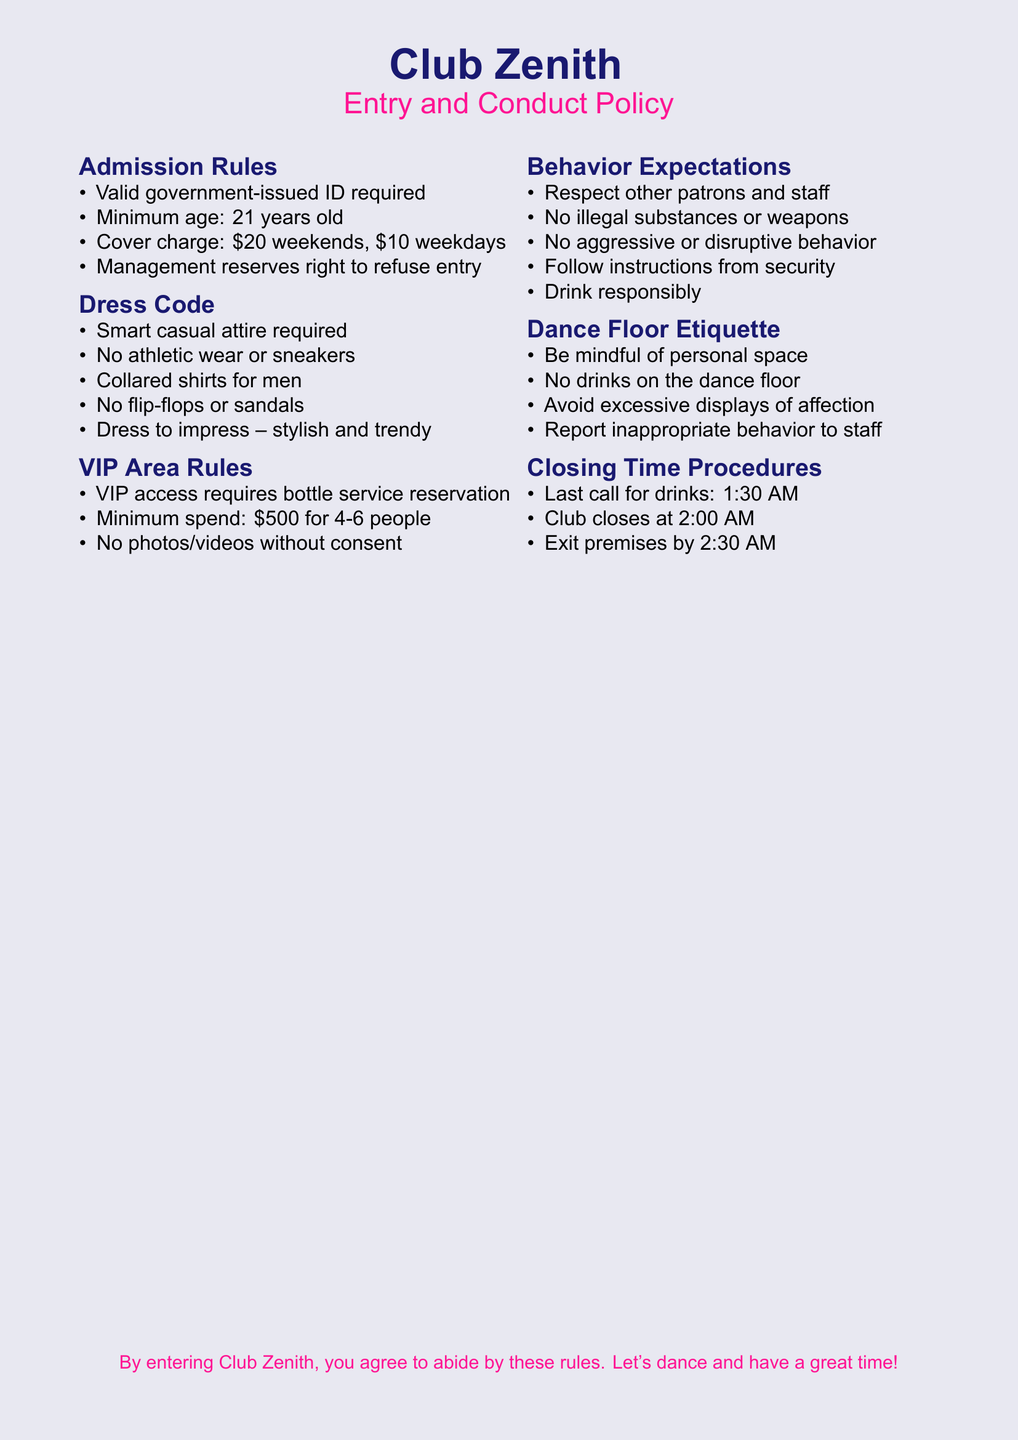What is the minimum age for entry? The minimum age for entry is specified in the admission rules section of the document.
Answer: 21 years old What is the cover charge on weekends? The cover charge is stated under admission rules for different days of the week.
Answer: $20 What attire is required for entry? The dress code section outlines the type of attire acceptable for entry into the nightclub.
Answer: Smart casual What is the minimum spend for VIP access? The VIP area rules mention the minimum spending requirement for accessing this area.
Answer: $500 What time does the club close? The closing time is detailed in the closing time procedures section of the document.
Answer: 2:00 AM Is athletic wear allowed? The dress code section specifies what types of attire are not permitted.
Answer: No What should you avoid on the dance floor? The dance floor etiquette section includes rules on behaviors to avoid while dancing.
Answer: Drinks What is expected of patrons regarding staff? The behavior expectations section outlines how patrons should interact with staff.
Answer: Respect What should you do if you see inappropriate behavior? The dance floor etiquette section advises on actions to take when witnessing such behavior.
Answer: Report to staff 